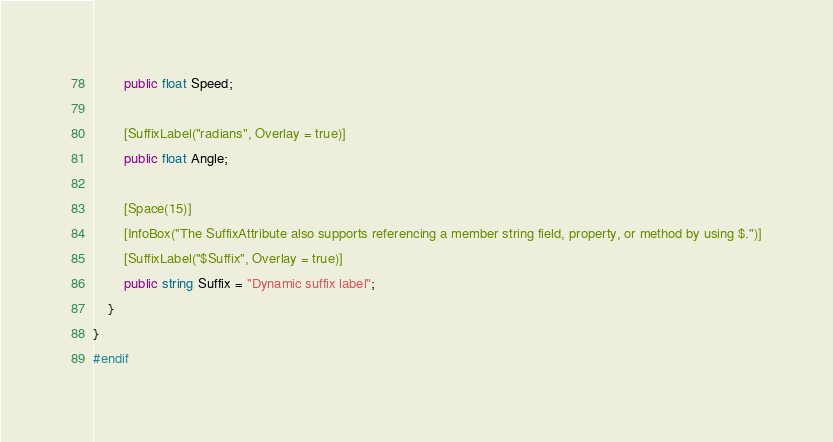<code> <loc_0><loc_0><loc_500><loc_500><_C#_>		public float Speed;

		[SuffixLabel("radians", Overlay = true)]
		public float Angle;

		[Space(15)]
		[InfoBox("The SuffixAttribute also supports referencing a member string field, property, or method by using $.")]
		[SuffixLabel("$Suffix", Overlay = true)]
		public string Suffix = "Dynamic suffix label";
	}
}
#endif
</code> 